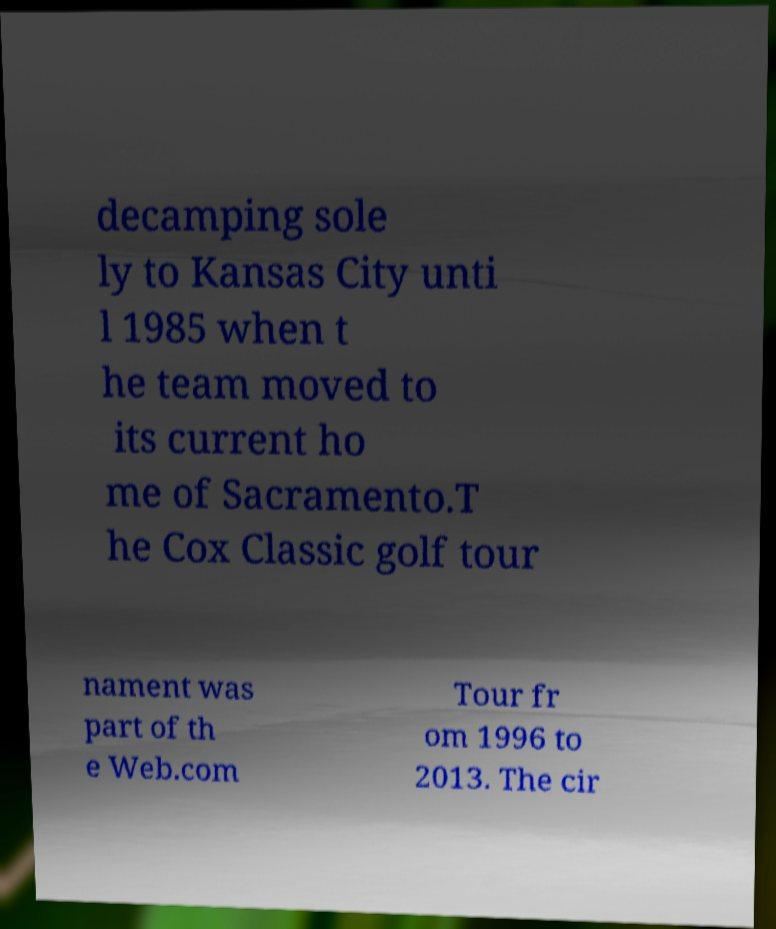Please identify and transcribe the text found in this image. decamping sole ly to Kansas City unti l 1985 when t he team moved to its current ho me of Sacramento.T he Cox Classic golf tour nament was part of th e Web.com Tour fr om 1996 to 2013. The cir 